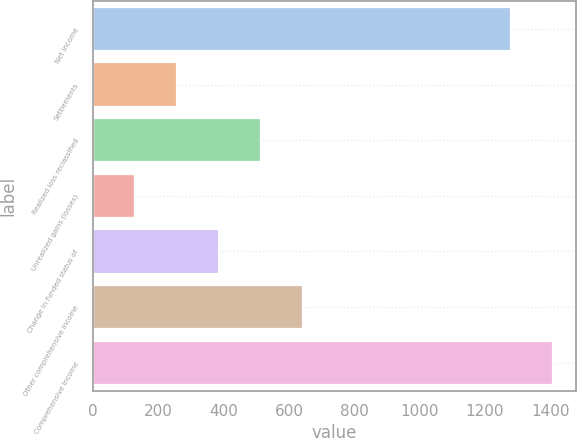<chart> <loc_0><loc_0><loc_500><loc_500><bar_chart><fcel>Net income<fcel>Settlements<fcel>Realized loss reclassified<fcel>Unrealized gains (losses)<fcel>Change in funded status of<fcel>Other comprehensive income<fcel>Comprehensive income<nl><fcel>1279<fcel>257.96<fcel>515.32<fcel>129.28<fcel>386.64<fcel>644<fcel>1407.68<nl></chart> 